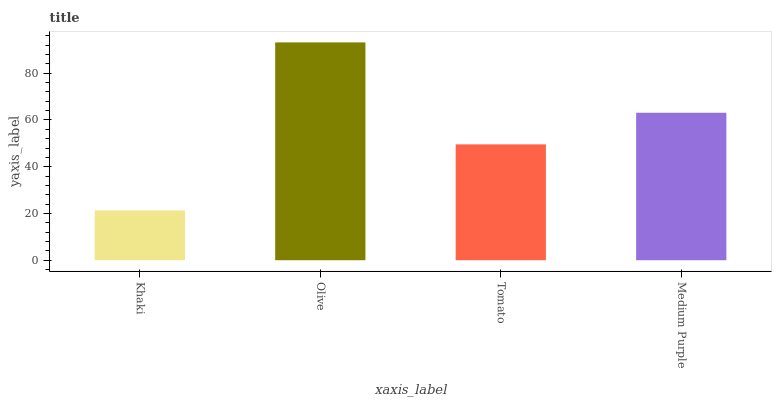Is Khaki the minimum?
Answer yes or no. Yes. Is Olive the maximum?
Answer yes or no. Yes. Is Tomato the minimum?
Answer yes or no. No. Is Tomato the maximum?
Answer yes or no. No. Is Olive greater than Tomato?
Answer yes or no. Yes. Is Tomato less than Olive?
Answer yes or no. Yes. Is Tomato greater than Olive?
Answer yes or no. No. Is Olive less than Tomato?
Answer yes or no. No. Is Medium Purple the high median?
Answer yes or no. Yes. Is Tomato the low median?
Answer yes or no. Yes. Is Tomato the high median?
Answer yes or no. No. Is Khaki the low median?
Answer yes or no. No. 